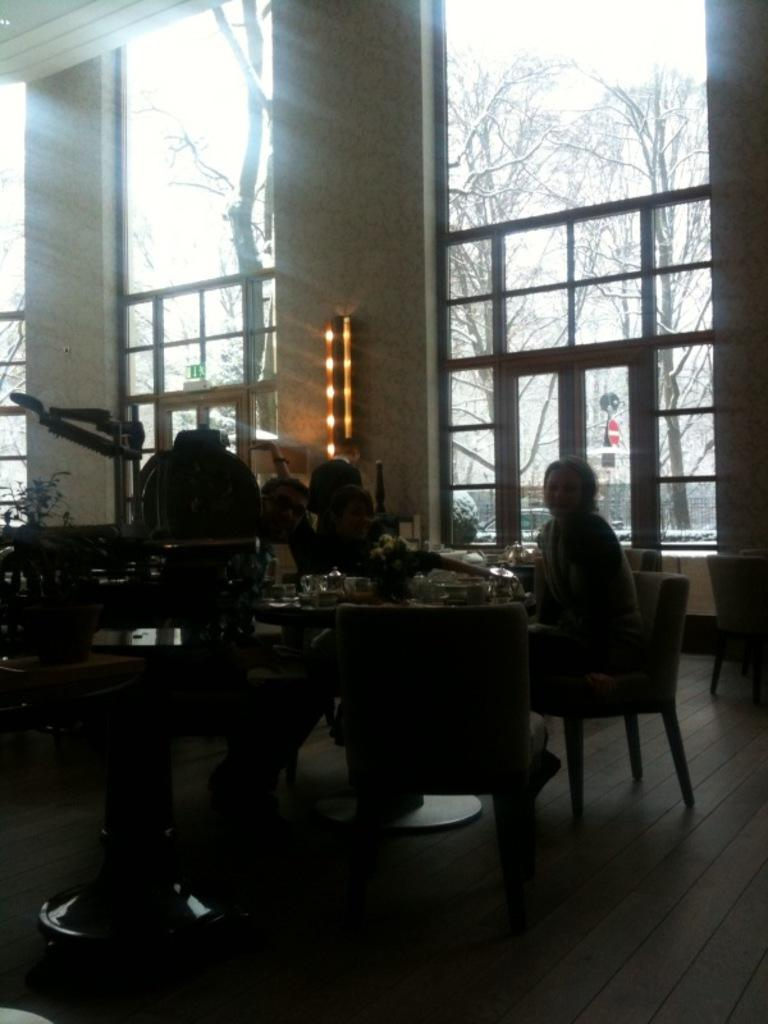How many people are in the image? There are three people in the image. What are the people doing in the image? The people are sitting on a chair. What is the facial expression of the people in the image? The people are smiling. What can be seen in the background of the image? There is a glass window and trees visible in the background of the image. What type of place is being pushed by the people in the image? There is no place being pushed by the people in the image; they are sitting on a chair and smiling. 